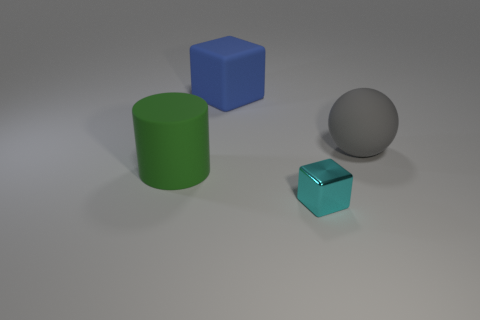There is a rubber thing in front of the rubber object right of the tiny cyan object; what shape is it?
Provide a succinct answer. Cylinder. What number of other things are there of the same color as the cylinder?
Provide a succinct answer. 0. Are the object right of the cyan metal cube and the block in front of the big green object made of the same material?
Your answer should be very brief. No. What size is the thing in front of the rubber cylinder?
Keep it short and to the point. Small. What material is the big blue object that is the same shape as the cyan thing?
Ensure brevity in your answer.  Rubber. Is there anything else that is the same size as the cyan shiny object?
Ensure brevity in your answer.  No. There is a big object in front of the ball; what is its shape?
Your answer should be compact. Cylinder. How many large blue matte objects have the same shape as the cyan thing?
Your answer should be compact. 1. Are there the same number of matte spheres to the left of the big green rubber cylinder and small cyan metallic things that are to the right of the big blue cube?
Your response must be concise. No. Are there any objects made of the same material as the green cylinder?
Your response must be concise. Yes. 